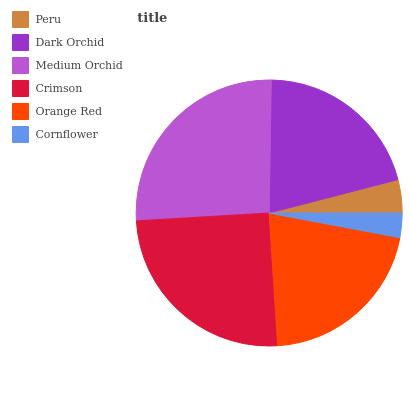Is Cornflower the minimum?
Answer yes or no. Yes. Is Medium Orchid the maximum?
Answer yes or no. Yes. Is Dark Orchid the minimum?
Answer yes or no. No. Is Dark Orchid the maximum?
Answer yes or no. No. Is Dark Orchid greater than Peru?
Answer yes or no. Yes. Is Peru less than Dark Orchid?
Answer yes or no. Yes. Is Peru greater than Dark Orchid?
Answer yes or no. No. Is Dark Orchid less than Peru?
Answer yes or no. No. Is Orange Red the high median?
Answer yes or no. Yes. Is Dark Orchid the low median?
Answer yes or no. Yes. Is Dark Orchid the high median?
Answer yes or no. No. Is Cornflower the low median?
Answer yes or no. No. 